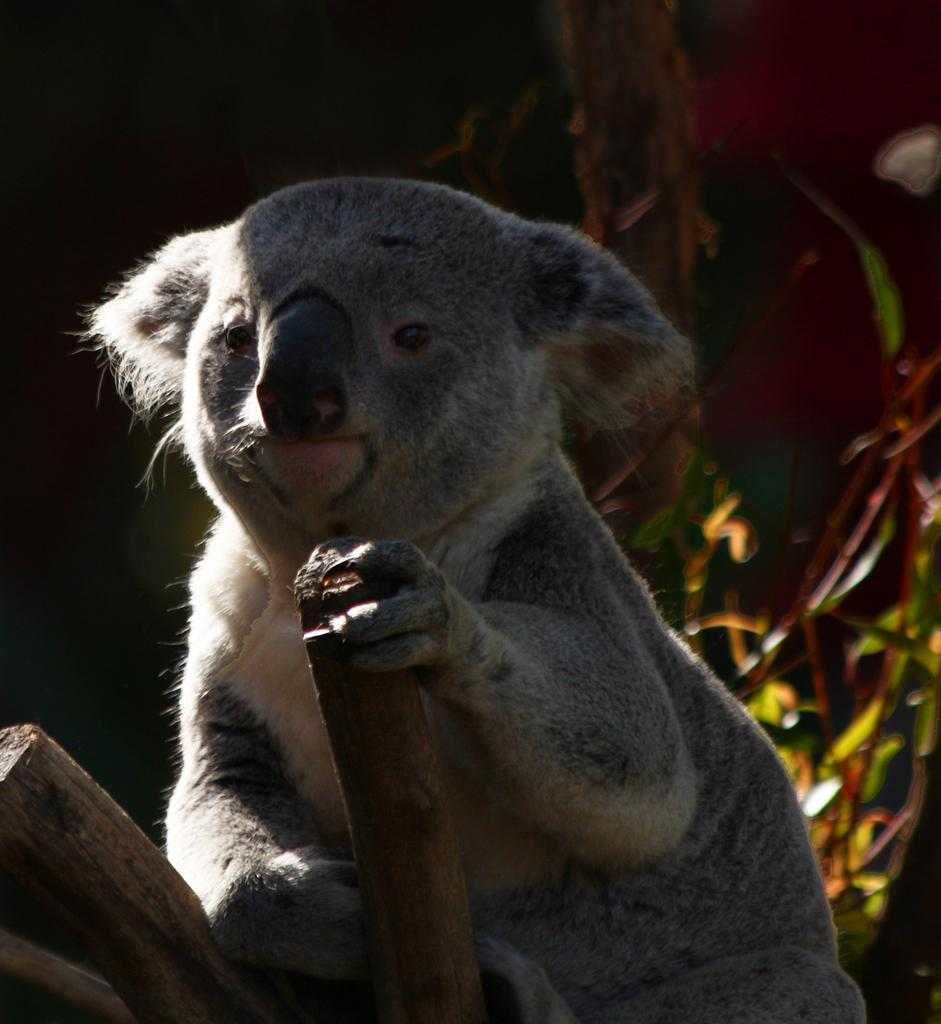What animal is the main subject of the picture? There is a koala in the picture. What is the koala holding in the image? The koala is holding a piece of wood. What can be seen in the background of the picture? There are plants and a wall visible in the background of the picture. What type of music is the koala playing on the branch in the image? There is no branch or music present in the image; it features a koala holding a piece of wood. 